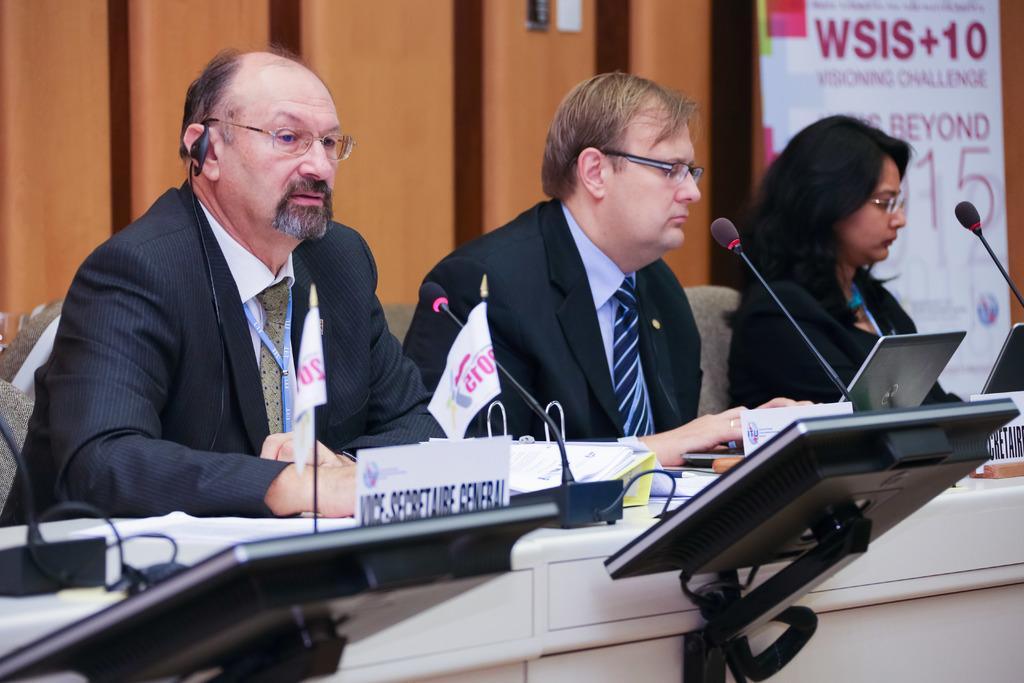In one or two sentences, can you explain what this image depicts? In this image we can see few persons are sitting on the chairs at the table. On the table we can see microphones, laptops, name boards, objects and monitors. In the background we can see a hoarding and objects on the wall. 